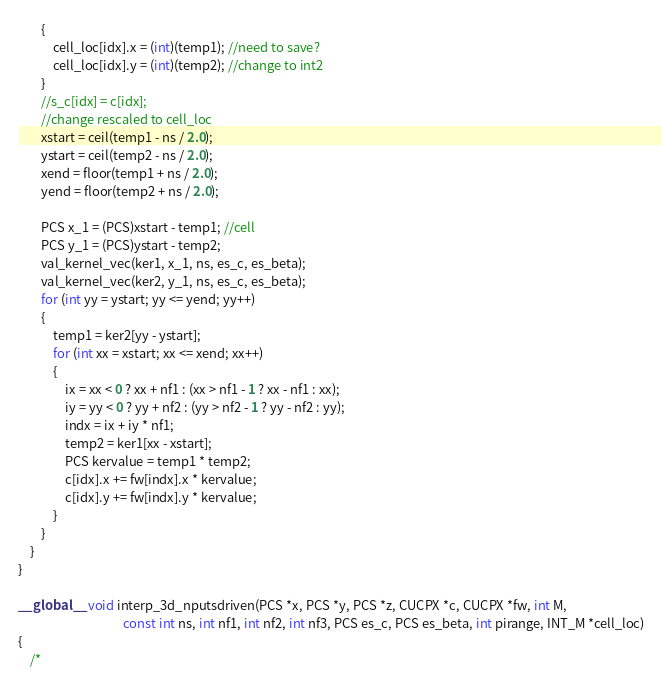<code> <loc_0><loc_0><loc_500><loc_500><_Cuda_>		{
			cell_loc[idx].x = (int)(temp1); //need to save?
			cell_loc[idx].y = (int)(temp2); //change to int2
		}
		//s_c[idx] = c[idx];
		//change rescaled to cell_loc
		xstart = ceil(temp1 - ns / 2.0);
		ystart = ceil(temp2 - ns / 2.0);
		xend = floor(temp1 + ns / 2.0);
		yend = floor(temp2 + ns / 2.0);

		PCS x_1 = (PCS)xstart - temp1; //cell
		PCS y_1 = (PCS)ystart - temp2;
		val_kernel_vec(ker1, x_1, ns, es_c, es_beta);
		val_kernel_vec(ker2, y_1, ns, es_c, es_beta);
		for (int yy = ystart; yy <= yend; yy++)
		{
			temp1 = ker2[yy - ystart];
			for (int xx = xstart; xx <= xend; xx++)
			{
				ix = xx < 0 ? xx + nf1 : (xx > nf1 - 1 ? xx - nf1 : xx);
				iy = yy < 0 ? yy + nf2 : (yy > nf2 - 1 ? yy - nf2 : yy);
				indx = ix + iy * nf1;
				temp2 = ker1[xx - xstart];
				PCS kervalue = temp1 * temp2;
				c[idx].x += fw[indx].x * kervalue;
			    c[idx].y += fw[indx].y * kervalue;
			}
		}
	}
}

__global__ void interp_3d_nputsdriven(PCS *x, PCS *y, PCS *z, CUCPX *c, CUCPX *fw, int M,
									const int ns, int nf1, int nf2, int nf3, PCS es_c, PCS es_beta, int pirange, INT_M *cell_loc)
{
	/*</code> 